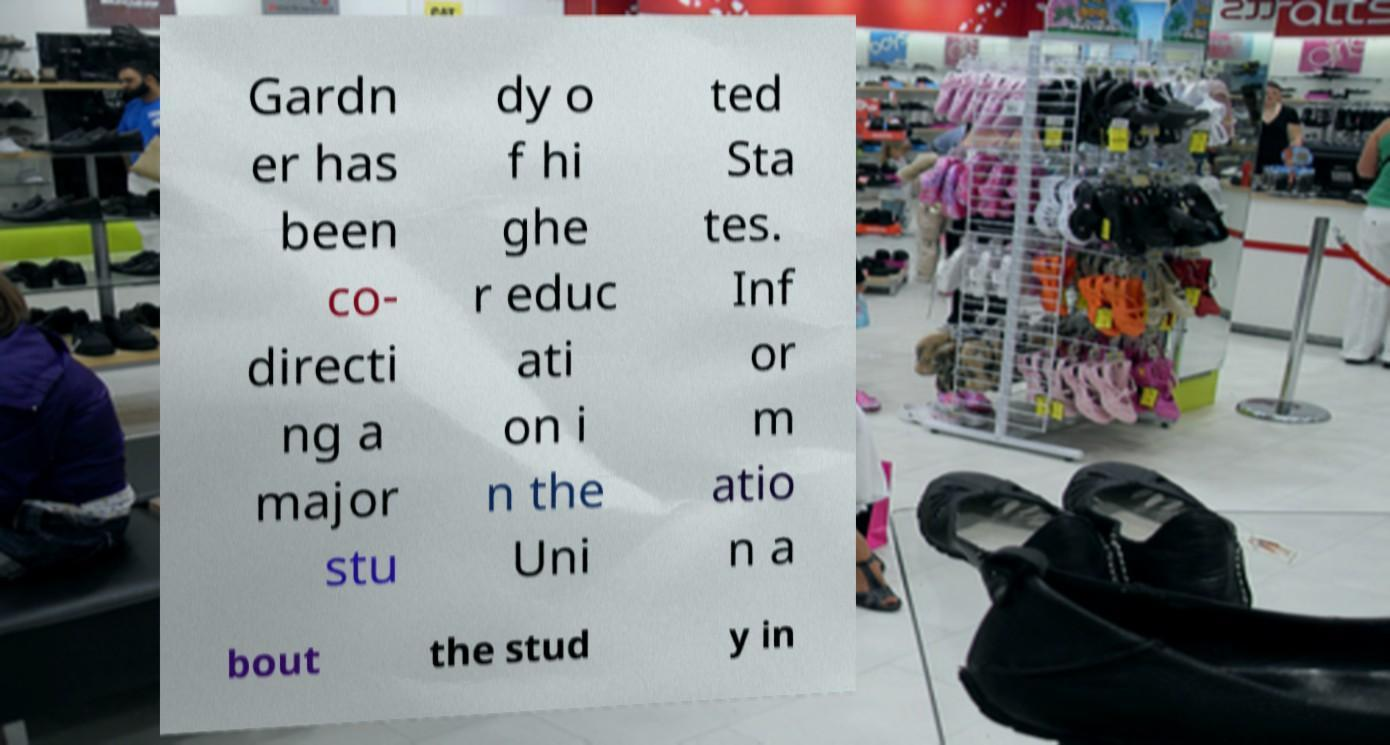Could you assist in decoding the text presented in this image and type it out clearly? Gardn er has been co- directi ng a major stu dy o f hi ghe r educ ati on i n the Uni ted Sta tes. Inf or m atio n a bout the stud y in 